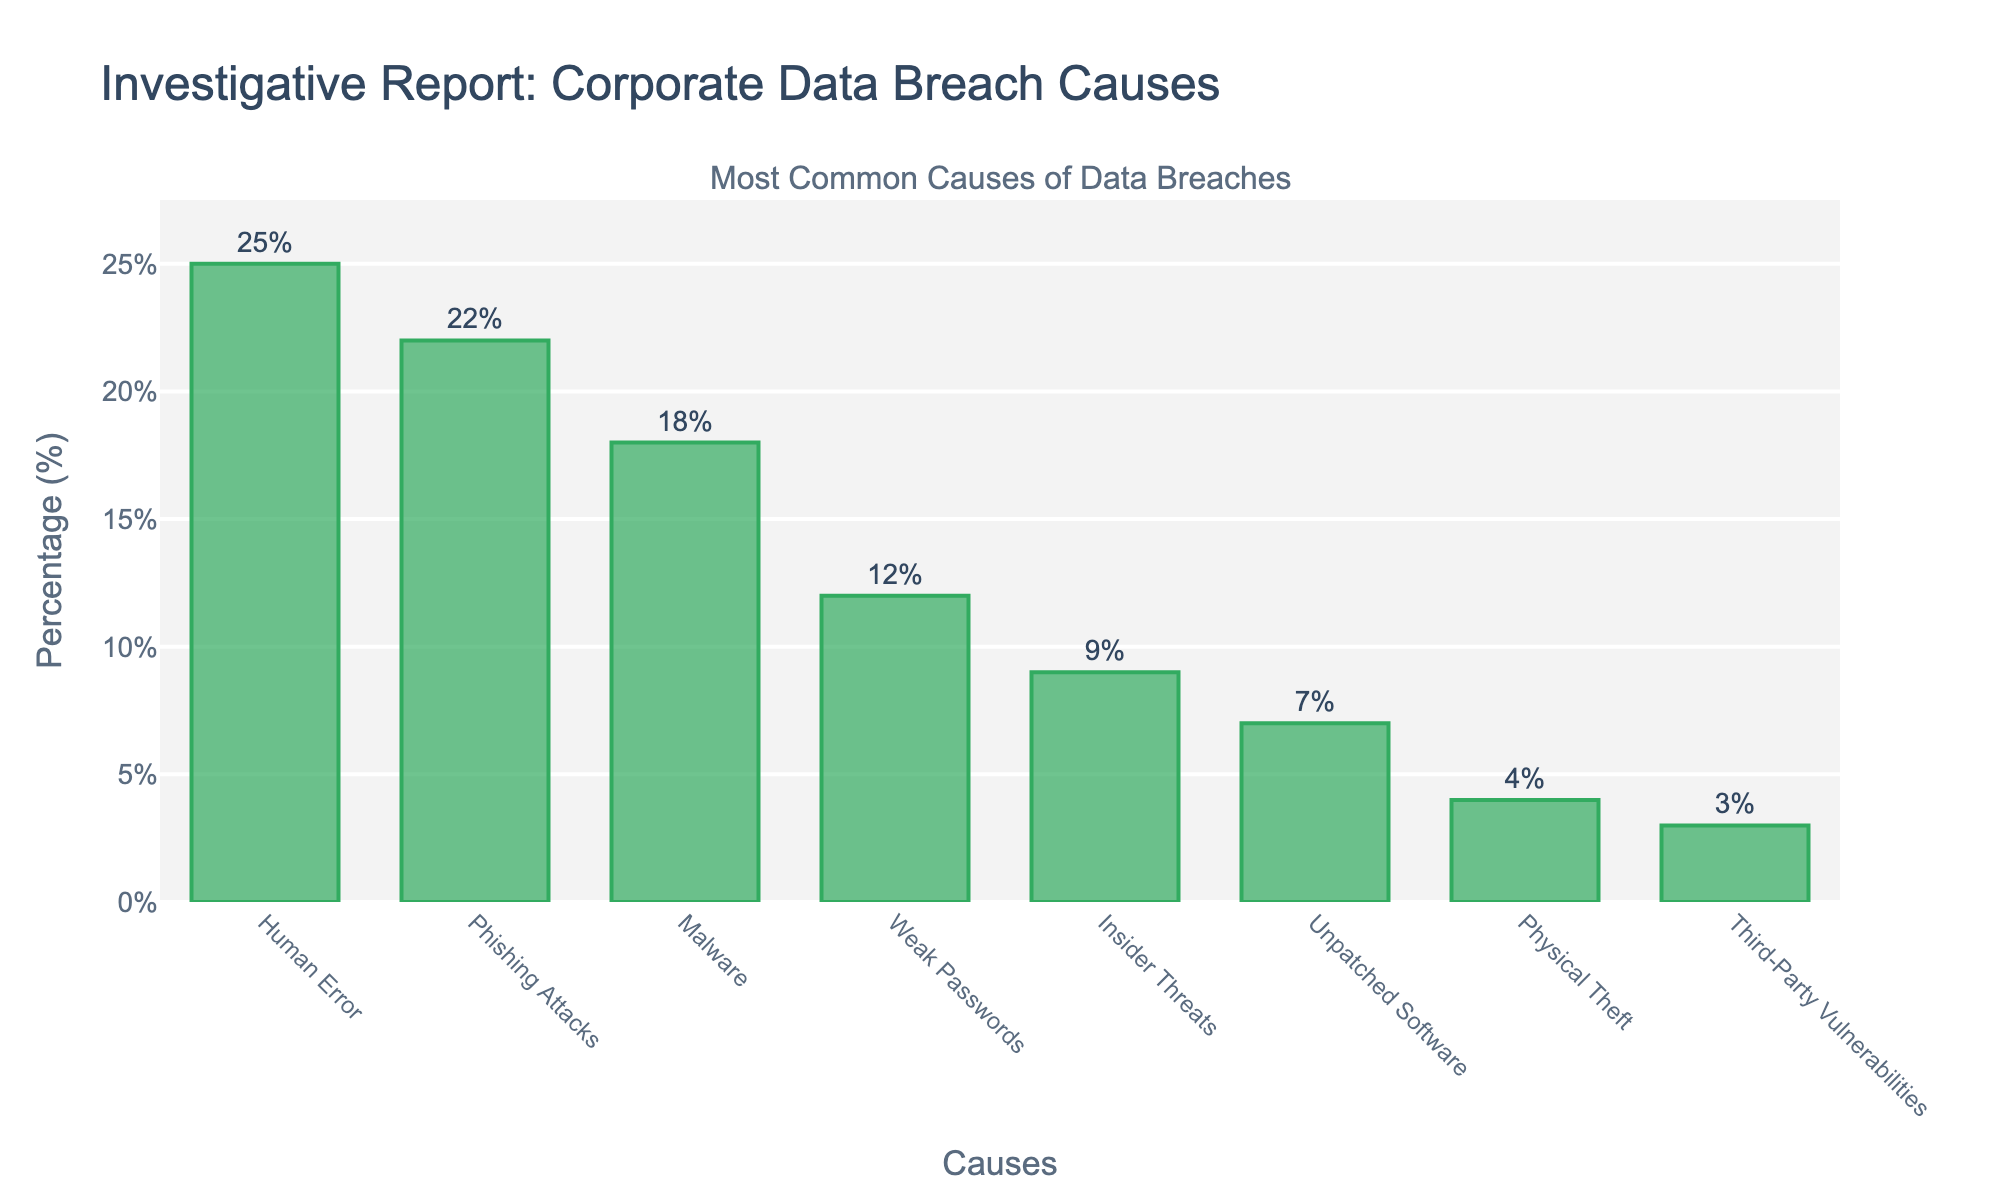What is the most common cause of data breaches in corporate environments? The chart shows the cause with the highest percentage bar. We can see that "Human Error" has the tallest bar with the label indicating 25%.
Answer: Human Error Which cause has a higher percentage, Phishing Attacks or Malware? By comparing the heights of the bars and the percentage labels, Phishing Attacks have 22% and Malware has 18%.
Answer: Phishing Attacks What is the combined percentage of data breaches caused by Weak Passwords and Insider Threats? Adding the percentages for Weak Passwords (12%) and Insider Threats (9%): \(12 + 9 = 21\% \).
Answer: 21% Between Unpatched Software and Physical Theft, which has a greater impact on data breaches? The bar associated with Unpatched Software shows 7%, whereas Physical Theft shows 4%. Therefore, Unpatched Software has a greater impact.
Answer: Unpatched Software What percentage difference is there between the leading cause and the least common cause of data breaches? The most common cause is Human Error at 25%, and the least common cause is Third-Party Vulnerabilities at 3%. The difference is \( 25\% - 3\% = 22\% \).
Answer: 22% Which two causes have the smallest difference in their percentages? Comparing the differences: Phishing Attacks (22%) and Malware (18%) have a difference of \( 22 - 18 = 4\% \), which is the smallest difference among all pairs.
Answer: Phishing Attacks and Malware What is the average percentage of data breaches caused by Human Error, Phishing Attacks, and Malware? Adding the percentages: \( 25 + 22 + 18 = 65 \). Dividing by the number of causes (3): \( 65 / 3 \approx 21.67\% \).
Answer: 21.67% How many causes have a percentage of 10% or higher? We count the causes with percentages greater than or equal to 10%: Human Error (25%), Phishing Attacks (22%), Malware (18%), and Weak Passwords (12%). There are 4 causes in total.
Answer: 4 What is the median percentage among all the listed causes of data breaches? Listing percentages in ascending order: 3, 4, 7, 9, 12, 18, 22, 25. With 8 values, the median is the average of the 4th and 5th values: \( (9 + 12) / 2 = 10.5\% \).
Answer: 10.5% Which cause contributes less than 10% to data breaches and has the next smallest percentage after Physical Theft? From the figure, the causes with percentages under 10% are Insider Threats (9%), Unpatched Software (7%), Physical Theft (4%), and Third-Party Vulnerabilities (3%). Following Physical Theft, Unpatched Software has the next smallest percentage.
Answer: Unpatched Software 